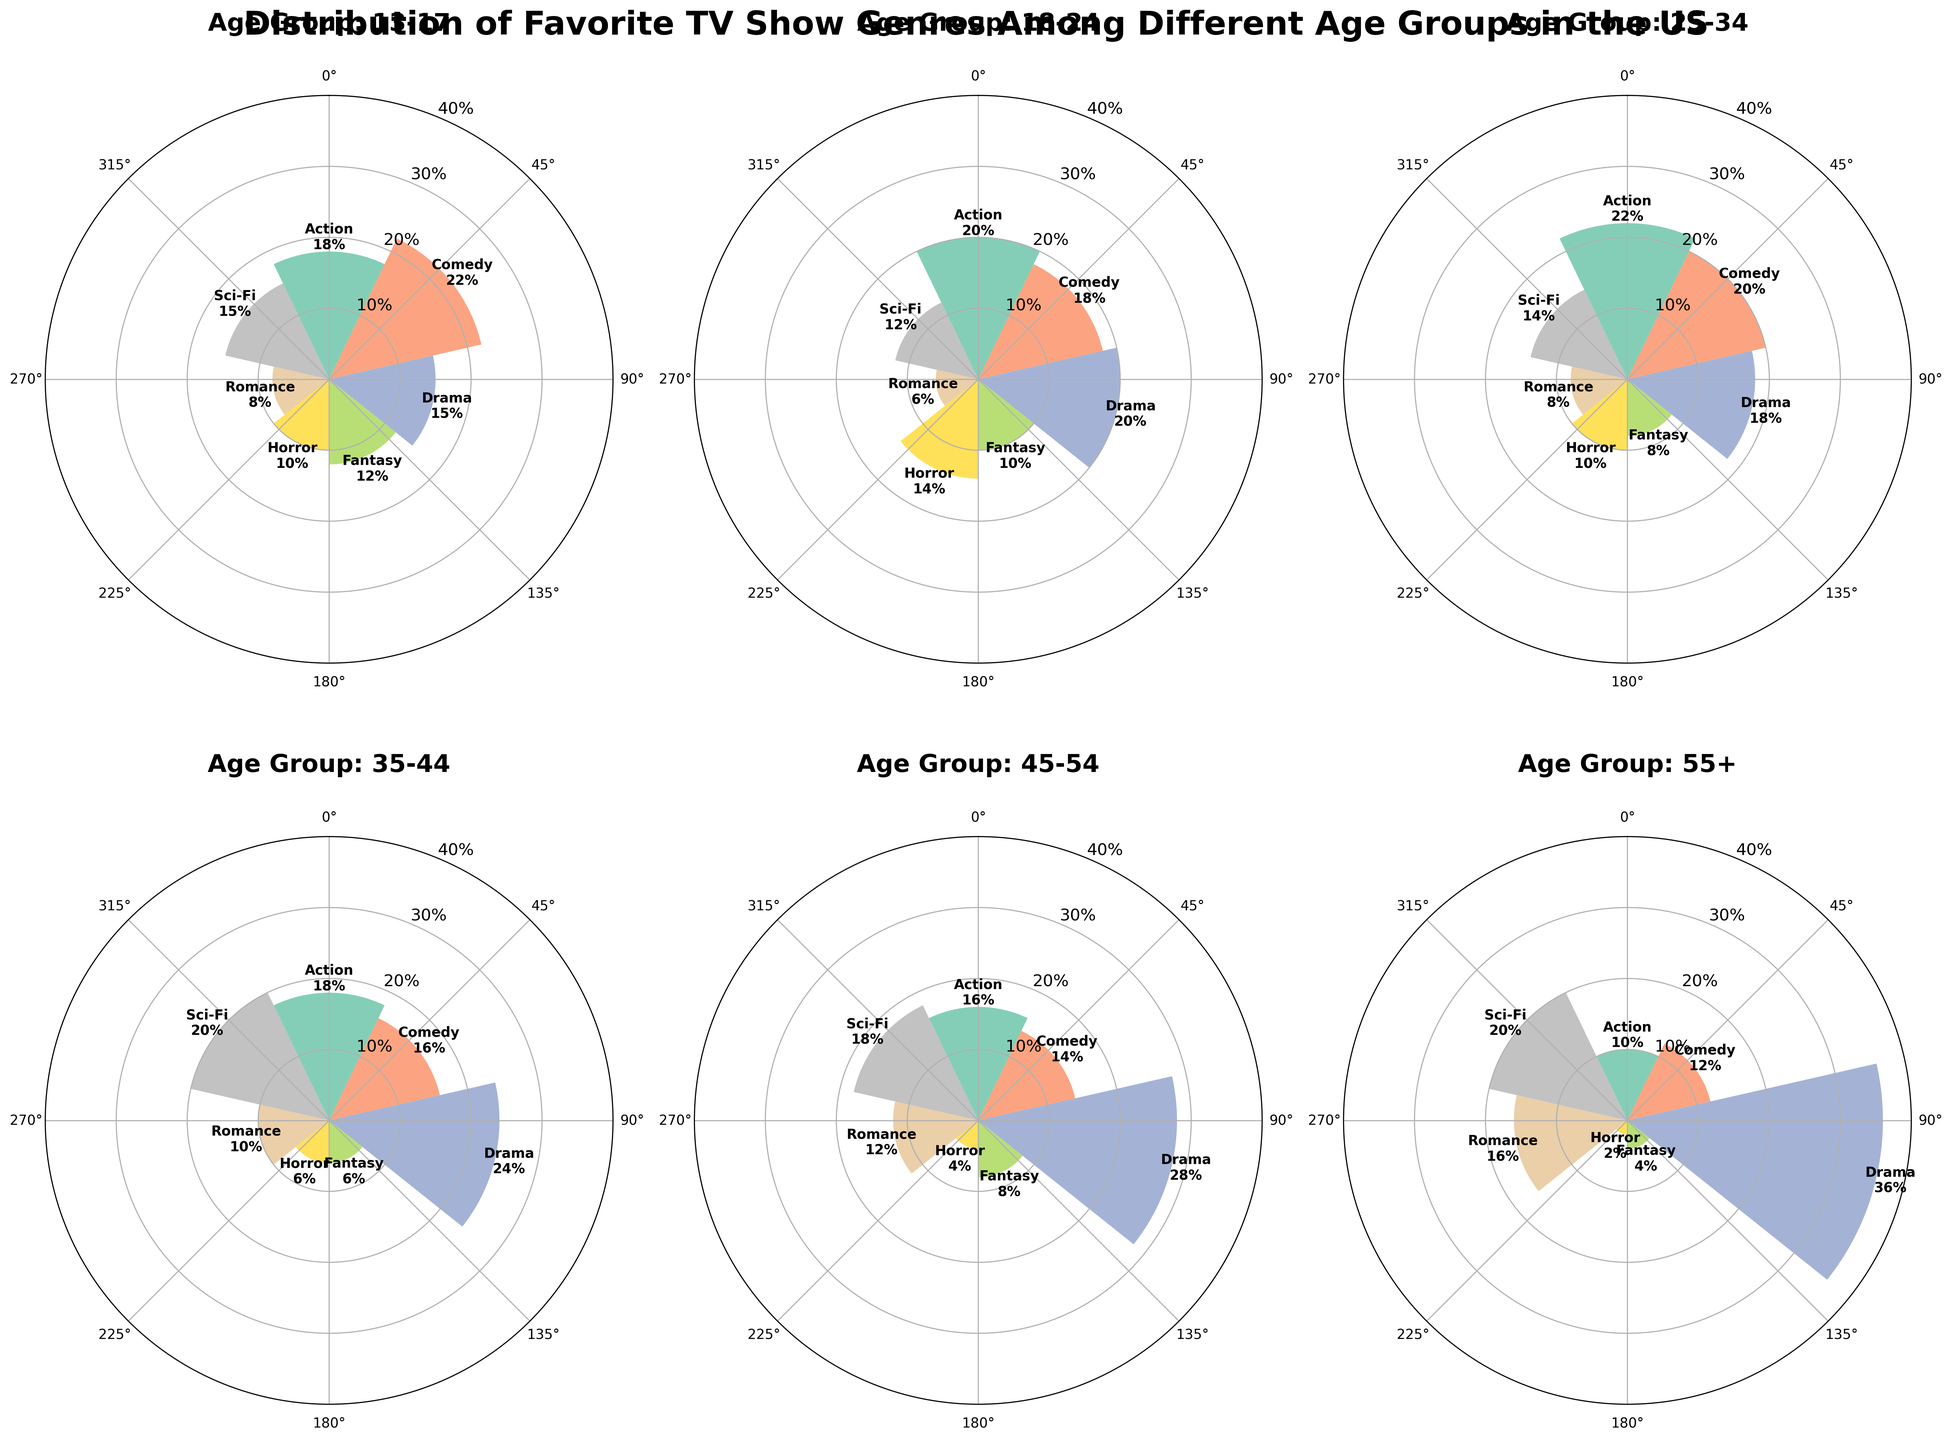Which age group has the highest preference for Drama? By looking at the rose chart for each age group, identify the one with the biggest segment for Drama. The "Drama" percentage for the 55+ age group is the highest at 36%.
Answer: 55+ What is the combined percentage of Action and Comedy for the 18-24 age group? The chart shows that the percentages for Action and Comedy in the 18-24 age group are 20% and 18%, respectively. Summing these values gives 38%.
Answer: 38% Compare the preference for Sci-Fi between the 45-54 and 55+ age groups. Which group prefers it more? The 45-54 age group has a Sci-Fi preference of 18%, while the 55+ age group has a preference of 20%. Thus, the 55+ group prefers Sci-Fi more.
Answer: 55+ Which genre has the least preference among the 13-17 age group and what is its percentage? By examining the 13-17 age group's chart, Romance has the smallest segment. The percentage for Romance is 8%.
Answer: Romance, 8% Is the Comedy preference greater than the Drama preference in the 25-34 age group? The 25-34 age group has a Comedy preference of 20% and a Drama preference of 18%. Since 20% is greater than 18%, the Comedy preference is indeed greater.
Answer: Yes Find the age group with the highest preference for Horror. By comparing the Horror segments across all age groups, the 18-24 age group has the highest preference at 14%.
Answer: 18-24 What is the percentage difference between Action and Sci-Fi preferences in the 35-44 age group? The chart shows that the 35-44 age group has an 18% preference for Action and 20% for Sci-Fi. The difference is
Answer: 2% Which genre shows a consistent percentage across all age groups? By evaluating the rose charts, Romance tends to vary, but Horror consistently remains relatively low across all age groups. The exact values vary, but Horror is consistently lower than the other genres.
Answer: Horror Compare the percentage of Fantasy preference between the youngest (13-17) and oldest (55+) age groups. What is the difference? The 13-17 group has a Fantasy preference of 12%, while the 55+ group has 4%. The difference between these is 8%.
Answer: 8% What is the average preference percentage for Comedy across all age groups? Summing the percentages for Comedy in all age groups (22+18+20+16+14+12) gives 102%. Dividing by the number of age groups, 6, gives an average of 17%.
Answer: 17% 